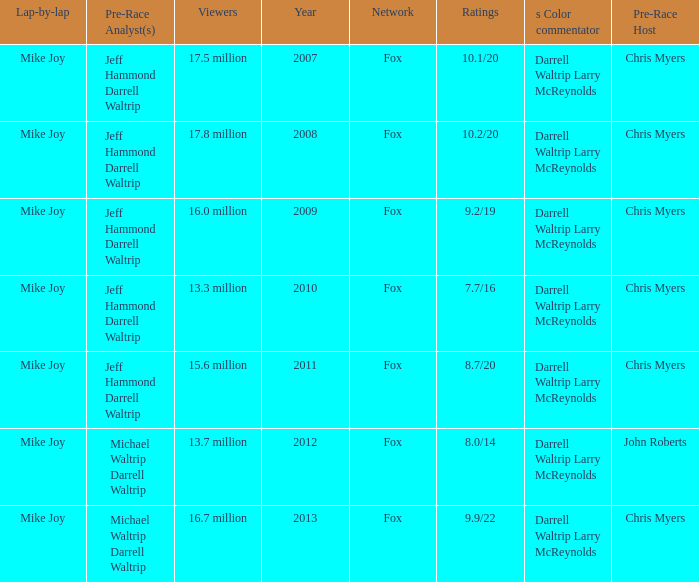Which Network has 17.5 million Viewers? Fox. 